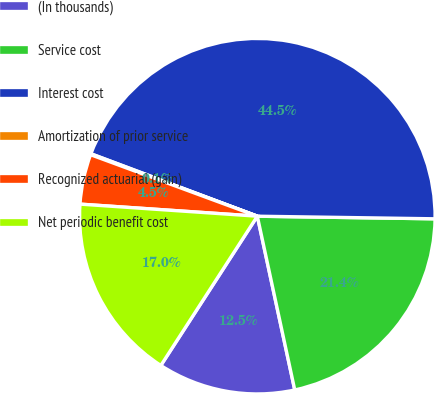Convert chart to OTSL. <chart><loc_0><loc_0><loc_500><loc_500><pie_chart><fcel>(In thousands)<fcel>Service cost<fcel>Interest cost<fcel>Amortization of prior service<fcel>Recognized actuarial (gain)<fcel>Net periodic benefit cost<nl><fcel>12.51%<fcel>21.39%<fcel>44.52%<fcel>0.09%<fcel>4.54%<fcel>16.95%<nl></chart> 